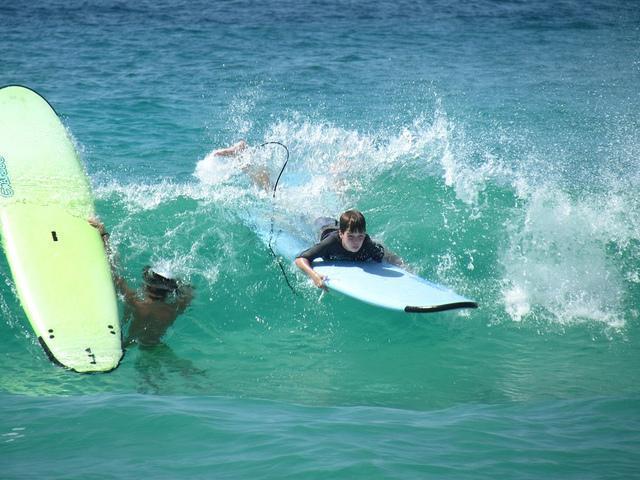How many people can you see?
Give a very brief answer. 2. How many surfboards are there?
Give a very brief answer. 2. How many black cars are in the picture?
Give a very brief answer. 0. 